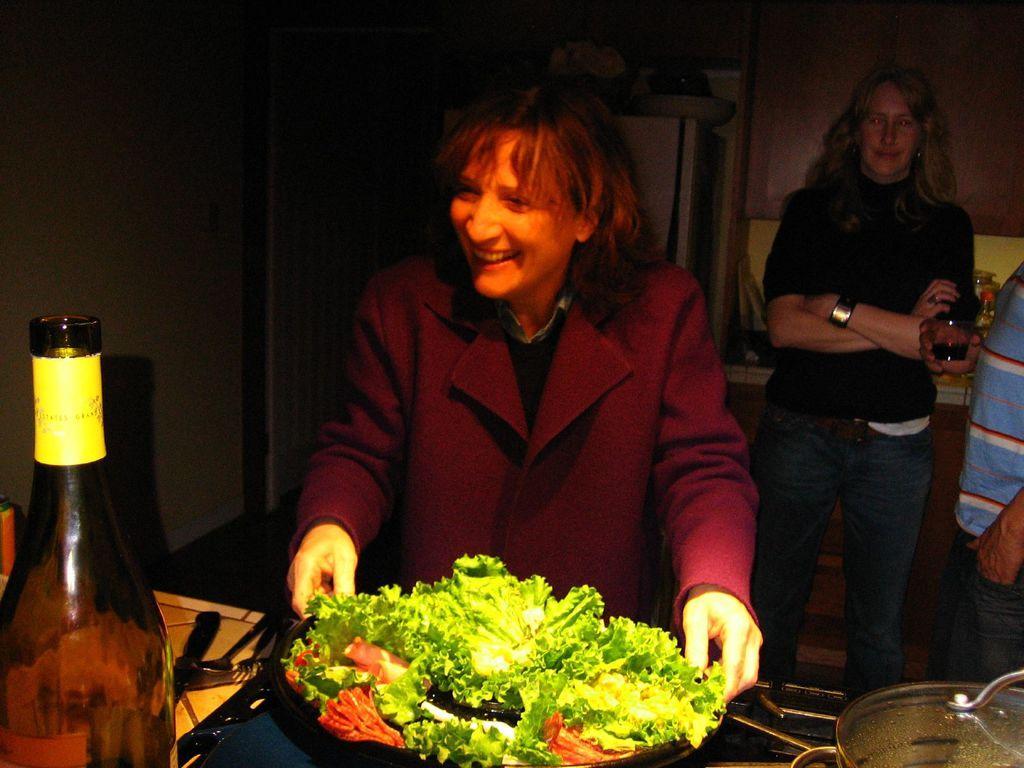Please provide a concise description of this image. In this picture there is a woman sitting and smiling, she has a table in front of her and there is a plate of salad served, there is also a wine bottle, some spoons, forks and knives. In the backdrop there is another woman standing and there is a wall. 